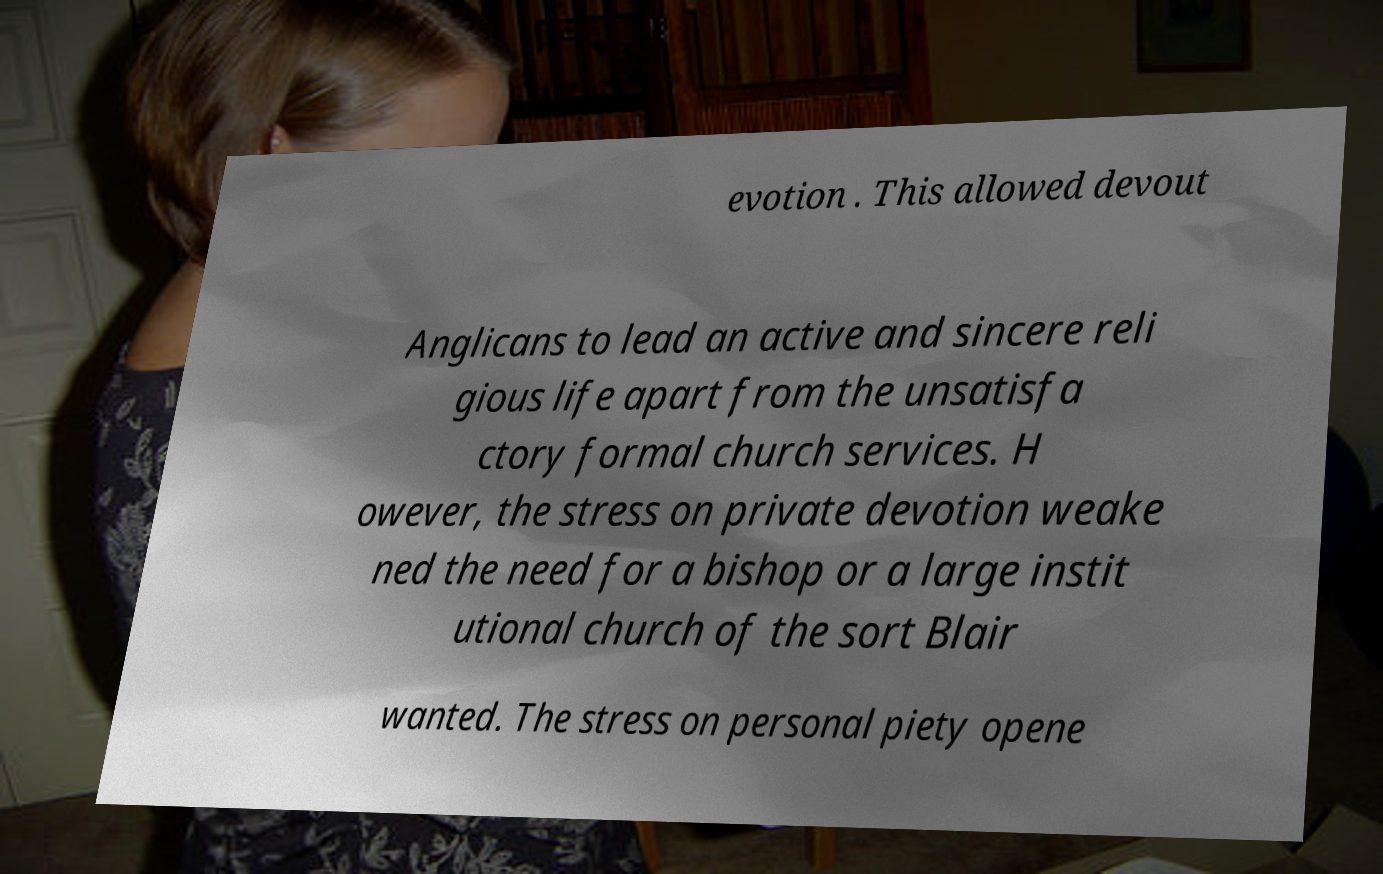What messages or text are displayed in this image? I need them in a readable, typed format. evotion . This allowed devout Anglicans to lead an active and sincere reli gious life apart from the unsatisfa ctory formal church services. H owever, the stress on private devotion weake ned the need for a bishop or a large instit utional church of the sort Blair wanted. The stress on personal piety opene 